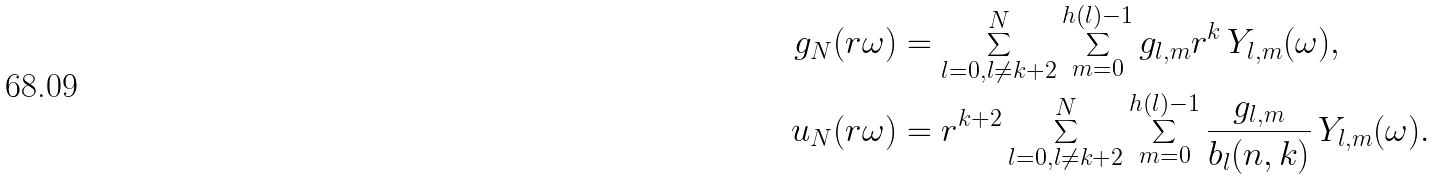<formula> <loc_0><loc_0><loc_500><loc_500>g _ { N } ( r \omega ) & = \sum _ { l = 0 , l \neq k + 2 } ^ { N } \sum _ { m = 0 } ^ { h ( l ) - 1 } g _ { l , m } r ^ { k } \, Y _ { l , m } ( \omega ) , \\ u _ { N } ( r \omega ) & = r ^ { k + 2 } \sum _ { l = 0 , l \neq k + 2 } ^ { N } \sum _ { m = 0 } ^ { h ( l ) - 1 } \frac { g _ { l , m } } { b _ { l } ( n , k ) } \, Y _ { l , m } ( \omega ) .</formula> 